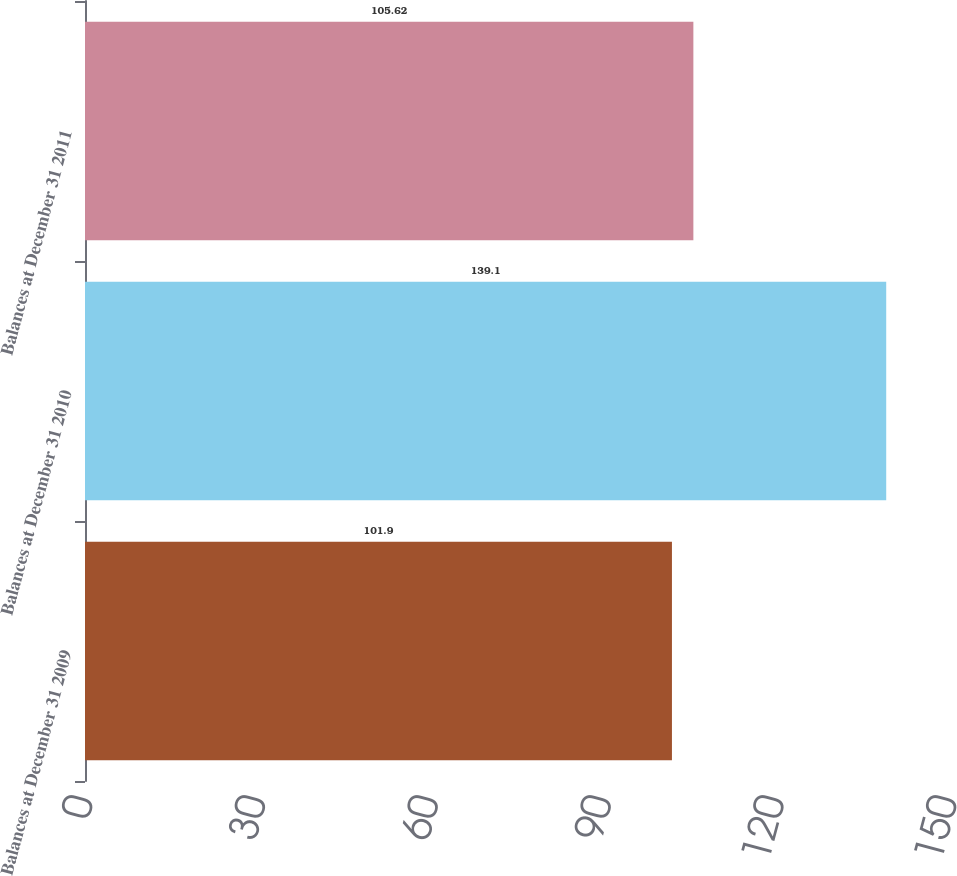<chart> <loc_0><loc_0><loc_500><loc_500><bar_chart><fcel>Balances at December 31 2009<fcel>Balances at December 31 2010<fcel>Balances at December 31 2011<nl><fcel>101.9<fcel>139.1<fcel>105.62<nl></chart> 